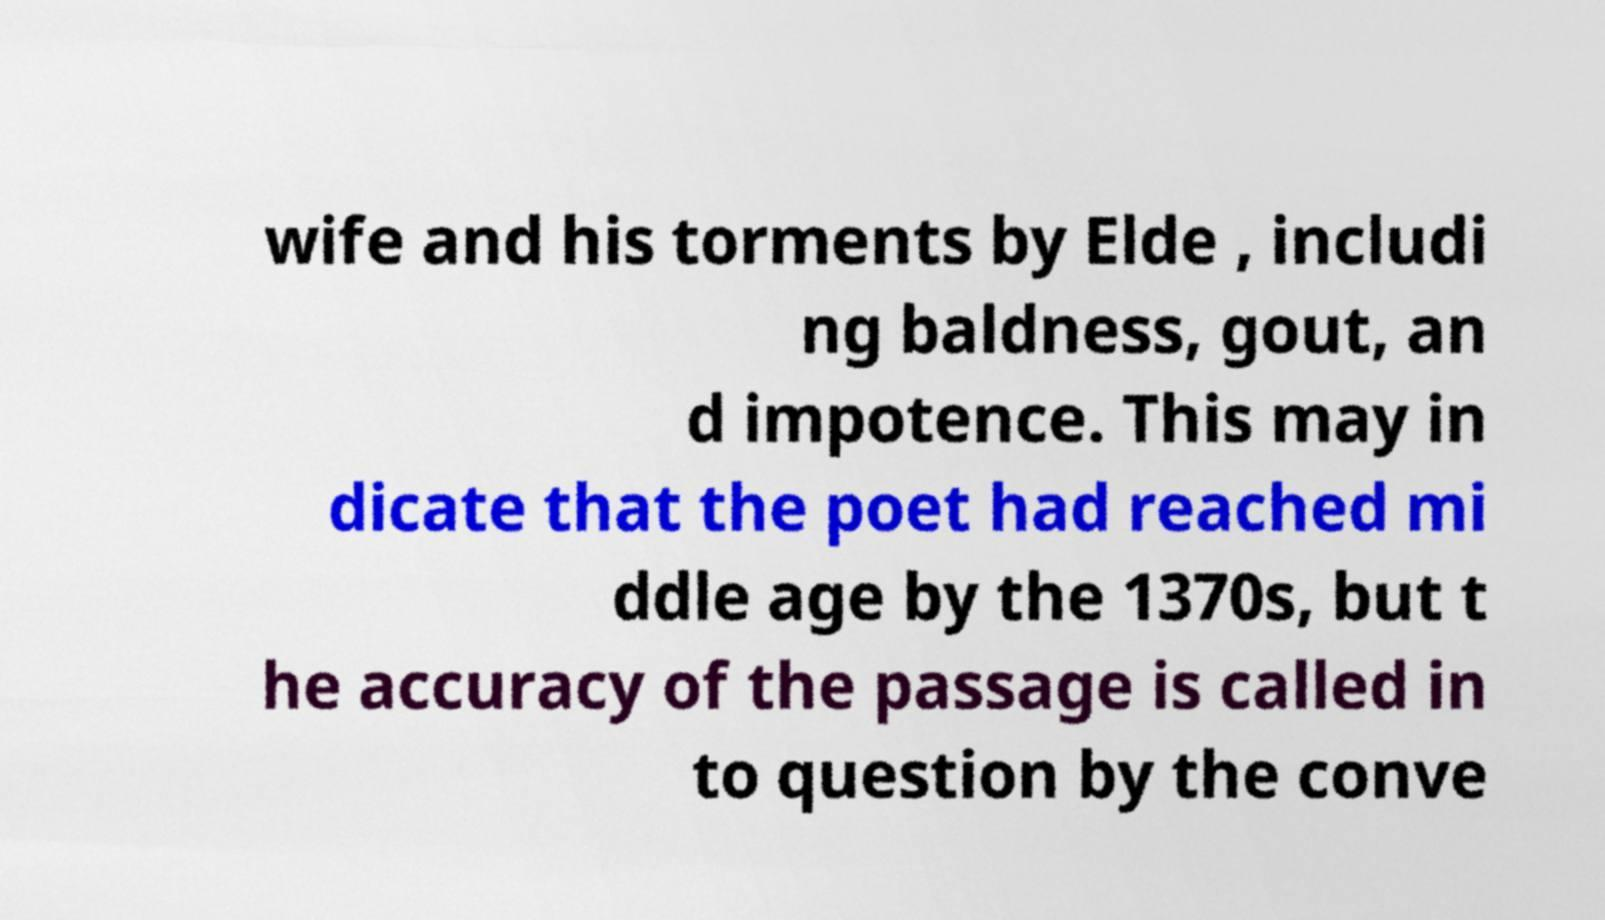Can you read and provide the text displayed in the image?This photo seems to have some interesting text. Can you extract and type it out for me? wife and his torments by Elde , includi ng baldness, gout, an d impotence. This may in dicate that the poet had reached mi ddle age by the 1370s, but t he accuracy of the passage is called in to question by the conve 